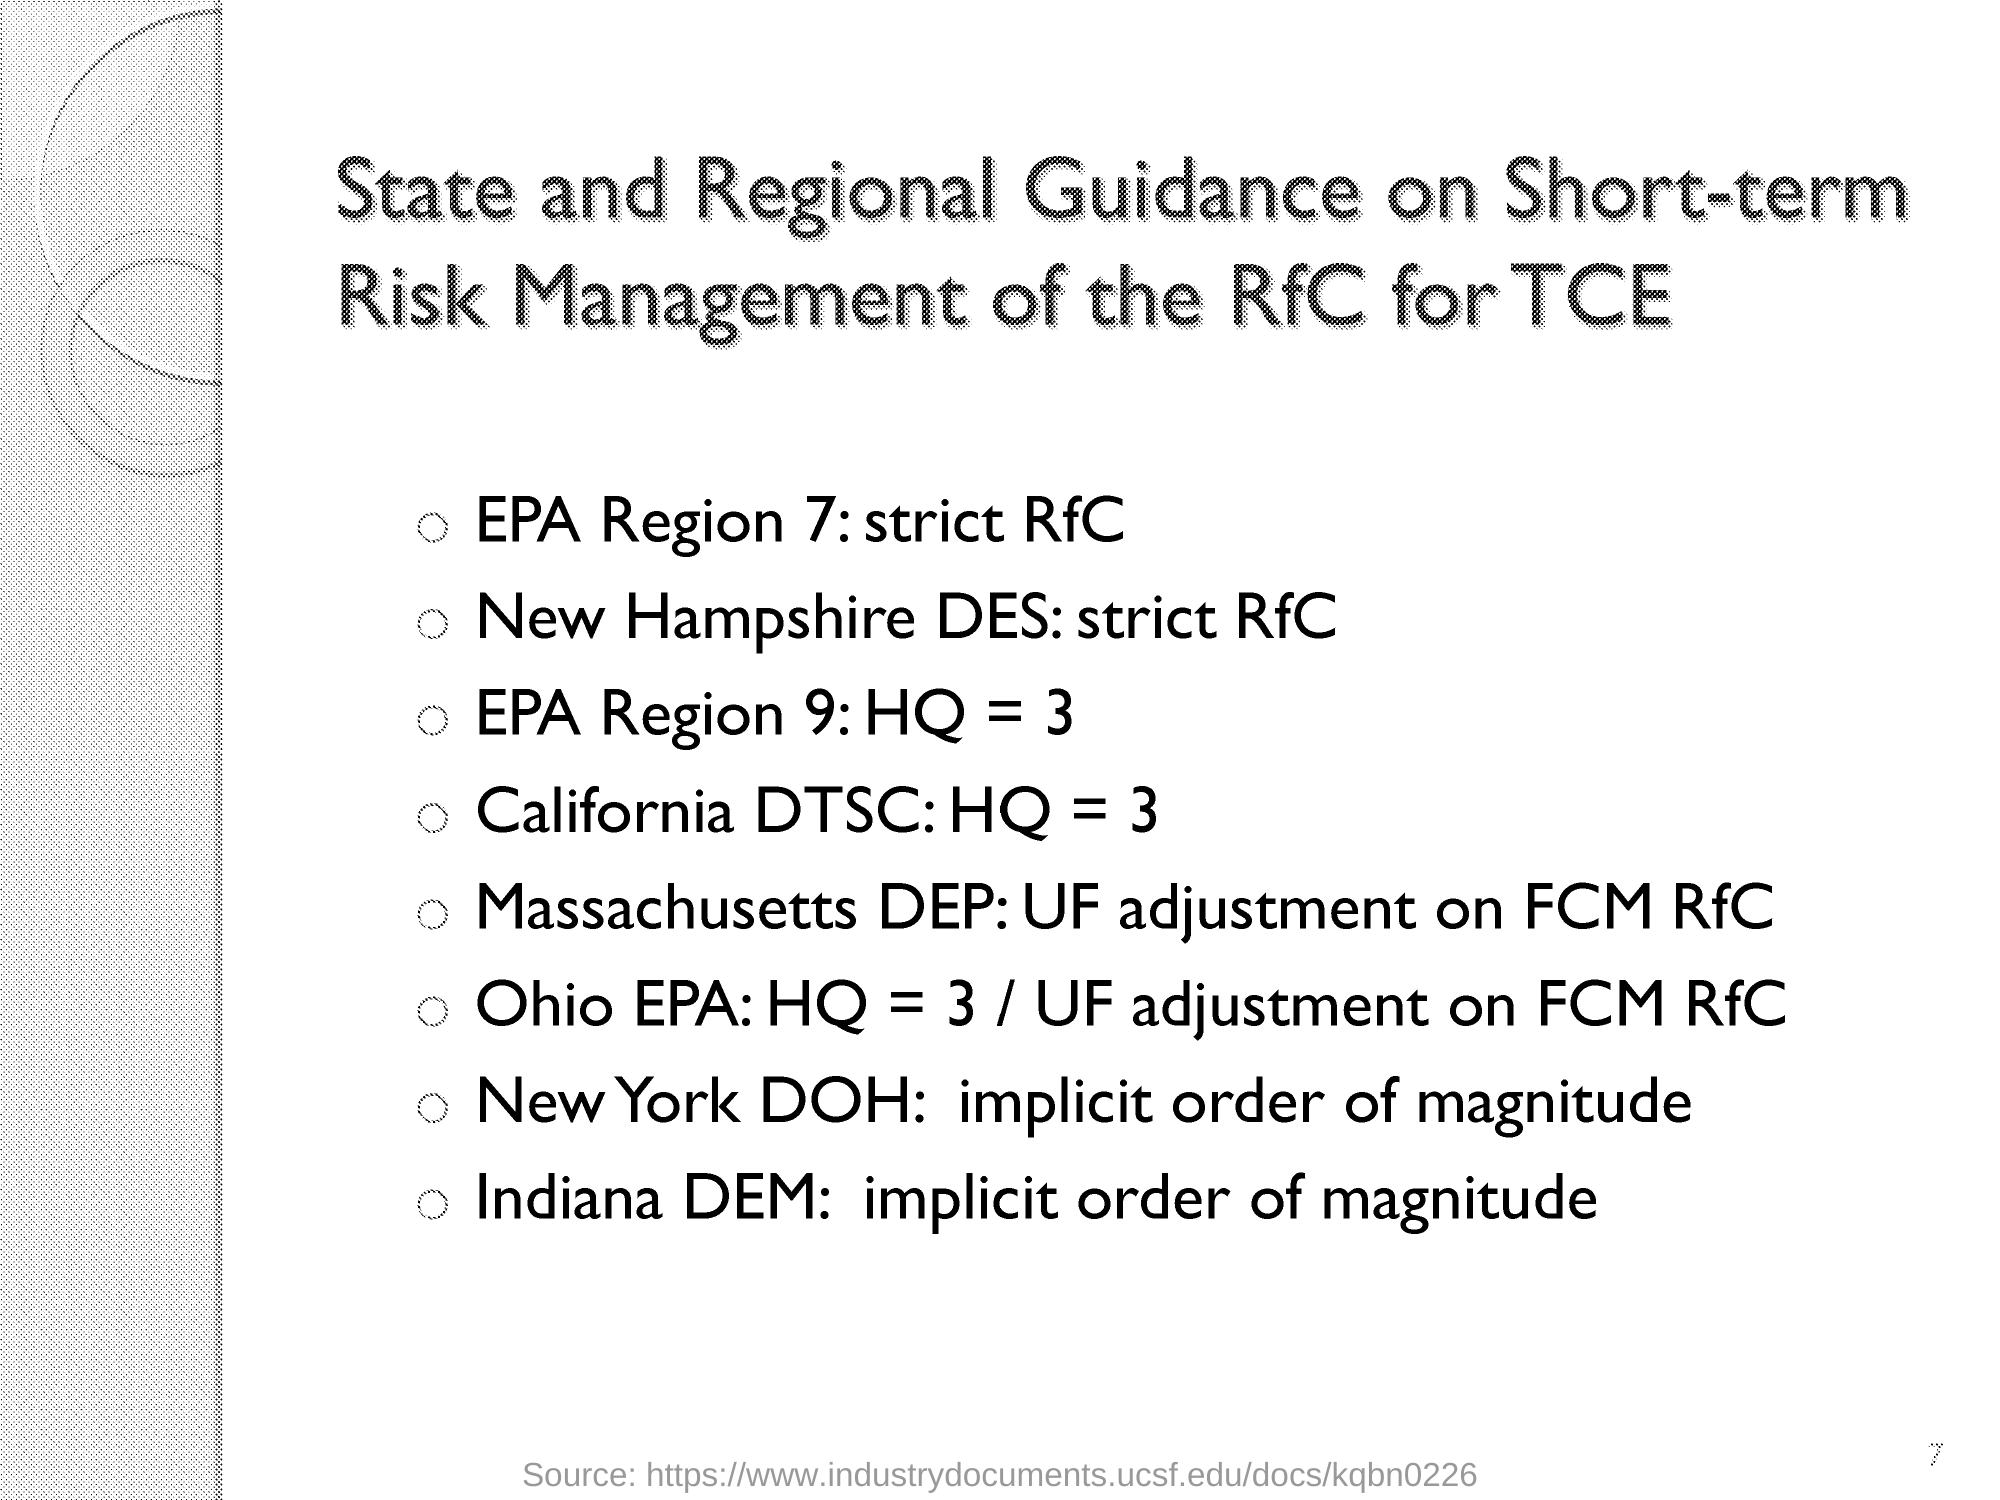What is the first REGION mentioned under "State and Regional Guidance on Short-term Risk Management of the RfC for TCE"?
Your answer should be compact. EPA Region 7. How "EPA Region 7 " should be managed according to "State and Regional Guidance on Short-term Risk Management"?
Offer a terse response. Strict RfC. How "New Hampshire DES" should be managed according to "State and Regional Guidance on Short-term Risk Management"?
Your answer should be very brief. Strict RfC. How "EPA Region 9" should be managed according to "State and Regional Guidance on Short-term Risk Management"?
Your answer should be very brief. HQ = 3. How "New York DOH" should be managed according to "State and Regional Guidance on Short-term Risk Management"?
Provide a succinct answer. Implicit order of magnitude. How "Indiana DEM" should be managed according to "State and Regional Guidance on Short-term Risk Management"?
Provide a succinct answer. Implicit order of magnitude. 